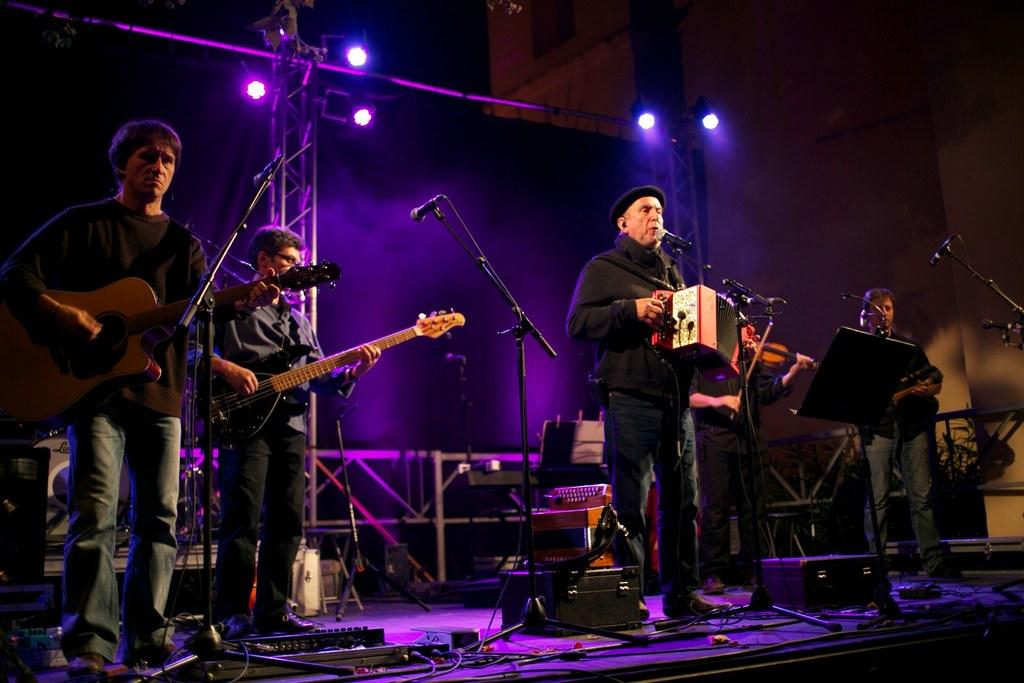What are the people on stage doing? The people on stage are holding guitars. How are the guitars positioned in relation to the people? The guitars are in their hands. What equipment is present in front of the people on stage? There are microphones (mics) in front of them. What type of smell can be detected coming from the guitars in the image? There is no indication of smell in the image, as it features people holding guitars on stage with microphones in front of them. --- Facts: 1. There is a car in the image. 2. The car is red. 3. The car has four wheels. 4. There is a road in the image. 5. The road is paved. Absurd Topics: bird, ocean, mountain Conversation: What is the main subject of the image? The main subject of the image is a car. What color is the car? The car is red. How many wheels does the car have? The car has four wheels. What is visible in the background of the image? There is a road in the image. What is the condition of the road? The road is paved. Reasoning: Let's think step by step in order to produce the conversation. We start by identifying the main subject of the image, which is the car. Next, we describe specific features of the car, such as its color and the number of wheels it has. Then, we observe the background of the image, noting that there is a road visible. Finally, we describe the condition of the road, which is paved. Absurd Question/Answer: Can you see any birds flying over the car in the image? There is no indication of birds in the image. 